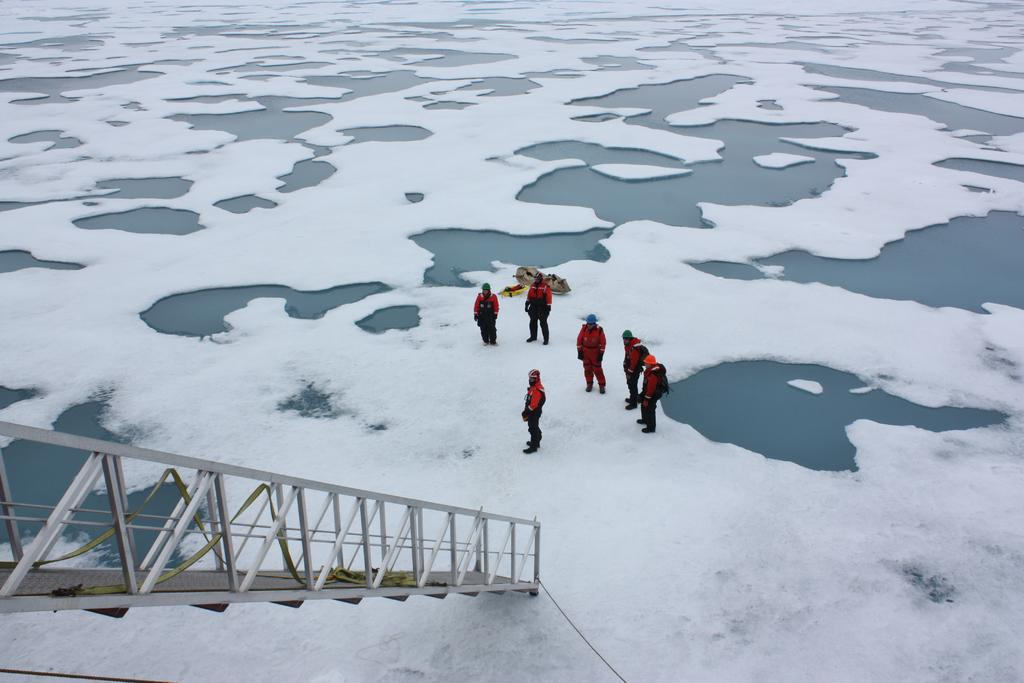What is the surface that the people are standing on in the image? The people are standing on the snow in the image. What else can be seen in the image besides the people and snow? There is water visible in the image. Can you describe the object on the left side of the image? There is a pole on the left side of the image. What type of comb is being used to groom the snow in the image? There is no comb present in the image, and the snow is not being groomed. 